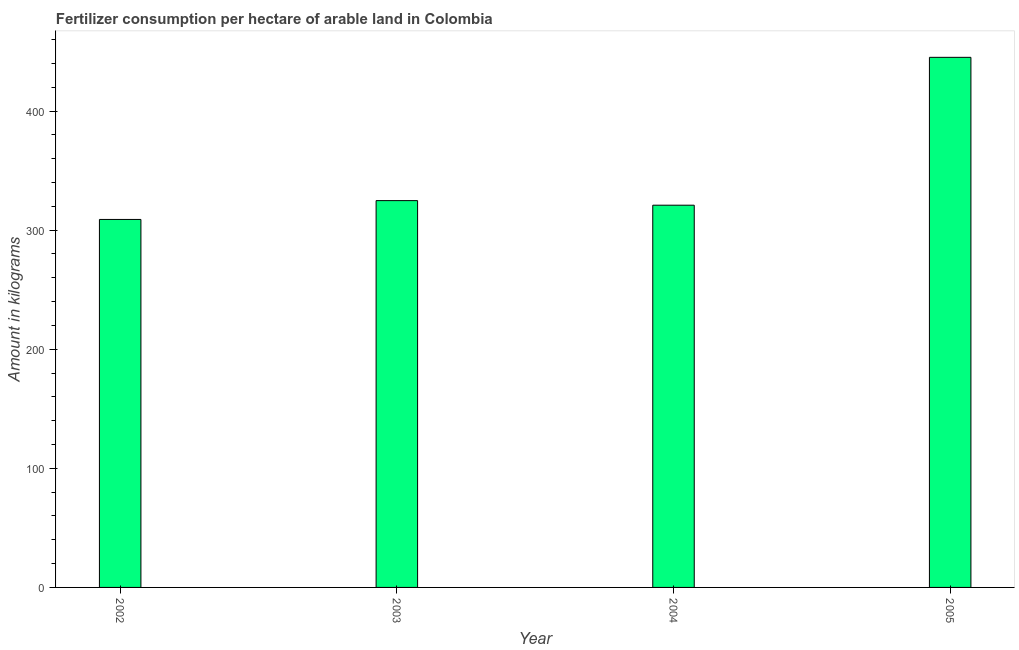Does the graph contain any zero values?
Keep it short and to the point. No. Does the graph contain grids?
Make the answer very short. No. What is the title of the graph?
Provide a succinct answer. Fertilizer consumption per hectare of arable land in Colombia . What is the label or title of the Y-axis?
Your answer should be compact. Amount in kilograms. What is the amount of fertilizer consumption in 2004?
Your response must be concise. 320.96. Across all years, what is the maximum amount of fertilizer consumption?
Ensure brevity in your answer.  445.13. Across all years, what is the minimum amount of fertilizer consumption?
Ensure brevity in your answer.  309. In which year was the amount of fertilizer consumption maximum?
Offer a very short reply. 2005. What is the sum of the amount of fertilizer consumption?
Make the answer very short. 1399.91. What is the difference between the amount of fertilizer consumption in 2002 and 2003?
Give a very brief answer. -15.81. What is the average amount of fertilizer consumption per year?
Give a very brief answer. 349.98. What is the median amount of fertilizer consumption?
Give a very brief answer. 322.89. Do a majority of the years between 2002 and 2003 (inclusive) have amount of fertilizer consumption greater than 100 kg?
Keep it short and to the point. Yes. What is the ratio of the amount of fertilizer consumption in 2002 to that in 2003?
Your answer should be compact. 0.95. Is the amount of fertilizer consumption in 2003 less than that in 2004?
Make the answer very short. No. What is the difference between the highest and the second highest amount of fertilizer consumption?
Your answer should be very brief. 120.32. Is the sum of the amount of fertilizer consumption in 2004 and 2005 greater than the maximum amount of fertilizer consumption across all years?
Provide a short and direct response. Yes. What is the difference between the highest and the lowest amount of fertilizer consumption?
Make the answer very short. 136.13. In how many years, is the amount of fertilizer consumption greater than the average amount of fertilizer consumption taken over all years?
Offer a terse response. 1. What is the Amount in kilograms of 2002?
Make the answer very short. 309. What is the Amount in kilograms of 2003?
Keep it short and to the point. 324.81. What is the Amount in kilograms in 2004?
Provide a short and direct response. 320.96. What is the Amount in kilograms in 2005?
Make the answer very short. 445.13. What is the difference between the Amount in kilograms in 2002 and 2003?
Your response must be concise. -15.81. What is the difference between the Amount in kilograms in 2002 and 2004?
Provide a succinct answer. -11.96. What is the difference between the Amount in kilograms in 2002 and 2005?
Ensure brevity in your answer.  -136.13. What is the difference between the Amount in kilograms in 2003 and 2004?
Offer a terse response. 3.85. What is the difference between the Amount in kilograms in 2003 and 2005?
Your response must be concise. -120.32. What is the difference between the Amount in kilograms in 2004 and 2005?
Provide a short and direct response. -124.17. What is the ratio of the Amount in kilograms in 2002 to that in 2003?
Keep it short and to the point. 0.95. What is the ratio of the Amount in kilograms in 2002 to that in 2004?
Your answer should be very brief. 0.96. What is the ratio of the Amount in kilograms in 2002 to that in 2005?
Your response must be concise. 0.69. What is the ratio of the Amount in kilograms in 2003 to that in 2005?
Your response must be concise. 0.73. What is the ratio of the Amount in kilograms in 2004 to that in 2005?
Your response must be concise. 0.72. 